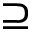Convert formula to latex. <formula><loc_0><loc_0><loc_500><loc_500>\supseteq</formula> 